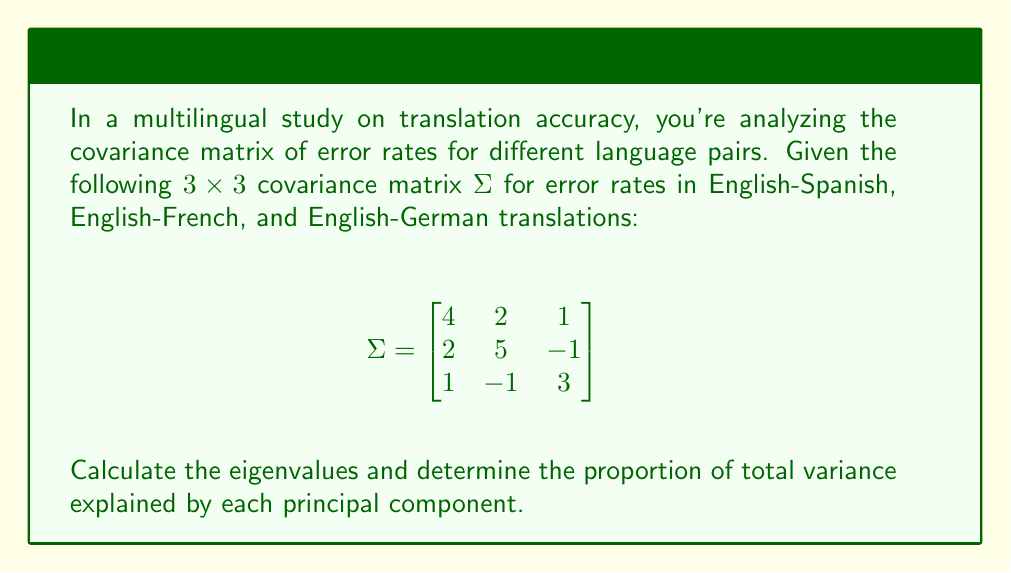Solve this math problem. To solve this problem, we'll follow these steps:

1) First, we need to find the eigenvalues of the covariance matrix $\Sigma$. The characteristic equation is:

   $\det(\Sigma - \lambda I) = 0$

   $$\begin{vmatrix}
   4-\lambda & 2 & 1 \\
   2 & 5-\lambda & -1 \\
   1 & -1 & 3-\lambda
   \end{vmatrix} = 0$$

2) Expanding this determinant:

   $(4-\lambda)[(5-\lambda)(3-\lambda)+1] - 2[2(3-\lambda)-1] + 1[2(-1)-(5-\lambda)] = 0$

3) Simplifying:

   $-\lambda^3 + 12\lambda^2 - 41\lambda + 40 = 0$

4) Solving this cubic equation (you might use a calculator or computer for this step), we get the eigenvalues:

   $\lambda_1 \approx 7.54$
   $\lambda_2 \approx 3.17$
   $\lambda_3 \approx 1.29$

5) The total variance is the sum of these eigenvalues:

   $\text{Total Variance} = 7.54 + 3.17 + 1.29 = 12$

6) The proportion of variance explained by each principal component is:

   PC1: $7.54 / 12 \approx 0.628$ or 62.8%
   PC2: $3.17 / 12 \approx 0.264$ or 26.4%
   PC3: $1.29 / 12 \approx 0.108$ or 10.8%
Answer: Eigenvalues: $\lambda_1 \approx 7.54$, $\lambda_2 \approx 3.17$, $\lambda_3 \approx 1.29$
Proportions: PC1 ≈ 62.8%, PC2 ≈ 26.4%, PC3 ≈ 10.8% 